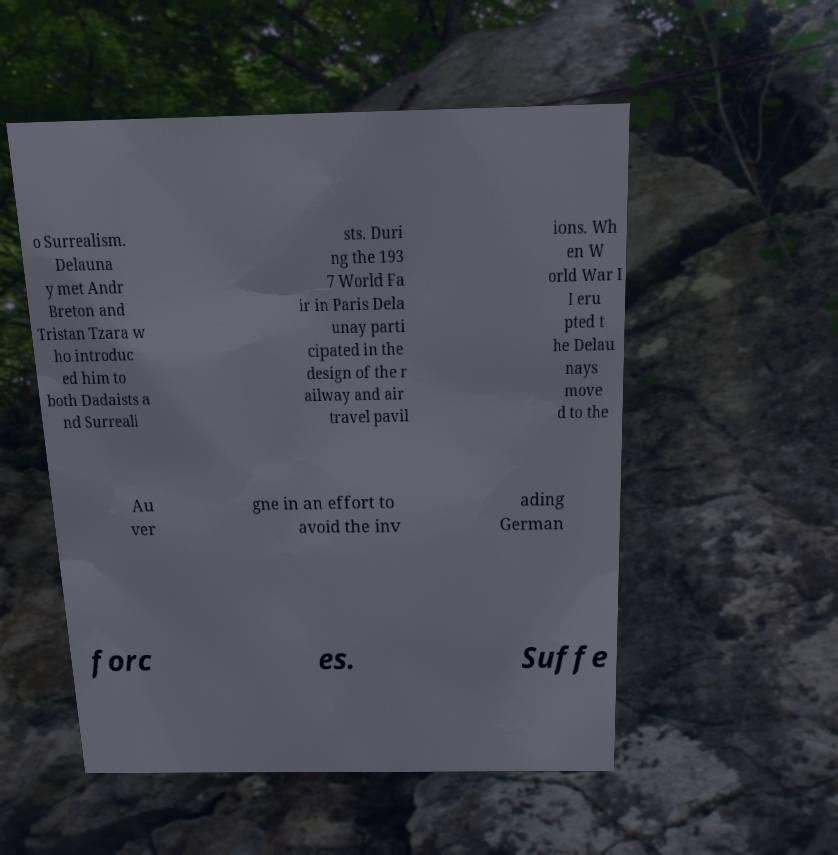What messages or text are displayed in this image? I need them in a readable, typed format. o Surrealism. Delauna y met Andr Breton and Tristan Tzara w ho introduc ed him to both Dadaists a nd Surreali sts. Duri ng the 193 7 World Fa ir in Paris Dela unay parti cipated in the design of the r ailway and air travel pavil ions. Wh en W orld War I I eru pted t he Delau nays move d to the Au ver gne in an effort to avoid the inv ading German forc es. Suffe 